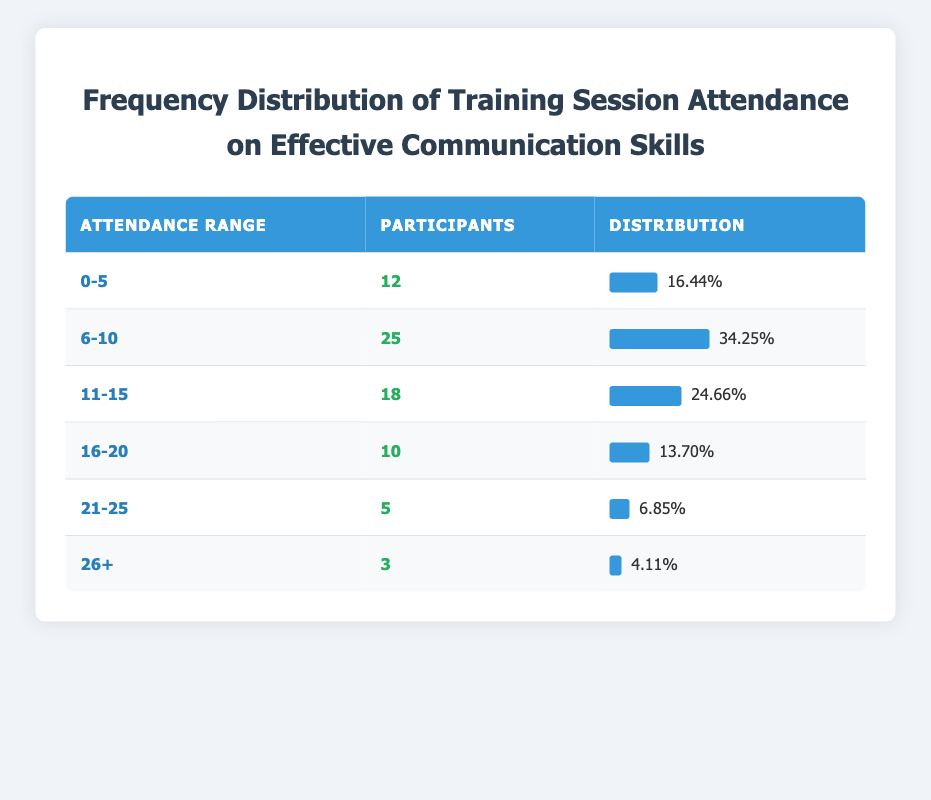What is the total number of participants across all attendance ranges? To find the total number of participants, we add the values in the "Participants" column: 12 + 25 + 18 + 10 + 5 + 3 = 73 participants.
Answer: 73 Which attendance range has the highest number of participants? By comparing the "Participants" values, the range "6-10" has the highest value with 25 participants.
Answer: 6-10 What percentage of participants attended 16 sessions or more? The total number of participants in the ranges 16-20, 21-25, and 26+ is 10 + 5 + 3 = 18. The total number of participants is 73. Thus, the percentage is (18/73) * 100 ≈ 24.66%.
Answer: 24.66% Is it true that more than half of the participants attended 10 sessions or fewer? To verify, we calculate the participants in the ranges 0-5 and 6-10: 12 + 25 = 37. It's necessary to compare this number to half of the total participants (73/2 = 36.5). Since 37 is greater than 36.5, it is true.
Answer: Yes What is the average number of participants for attendance ranges of 11-15 and 16-20? We first find the average of participants in the specified ranges: (18 + 10) / 2 = 14. Since there are two ranges, the average is 14.
Answer: 14 How many participants attended more than 10 sessions? We sum the participants in the ranges 11-15, 16-20, 21-25, and 26+: 18 + 10 + 5 + 3 = 36.
Answer: 36 What is the difference in the number of participants between the 11-15 and 21-25 attendance ranges? To find the difference, we subtract the number of participants in 21-25 from those in 11-15: 18 - 5 = 13.
Answer: 13 Which attendance range corresponds to the lowest percentage of participants? By examining the percentages, the lowest is for the range "26+" at approximately 4.11%.
Answer: 26+ 